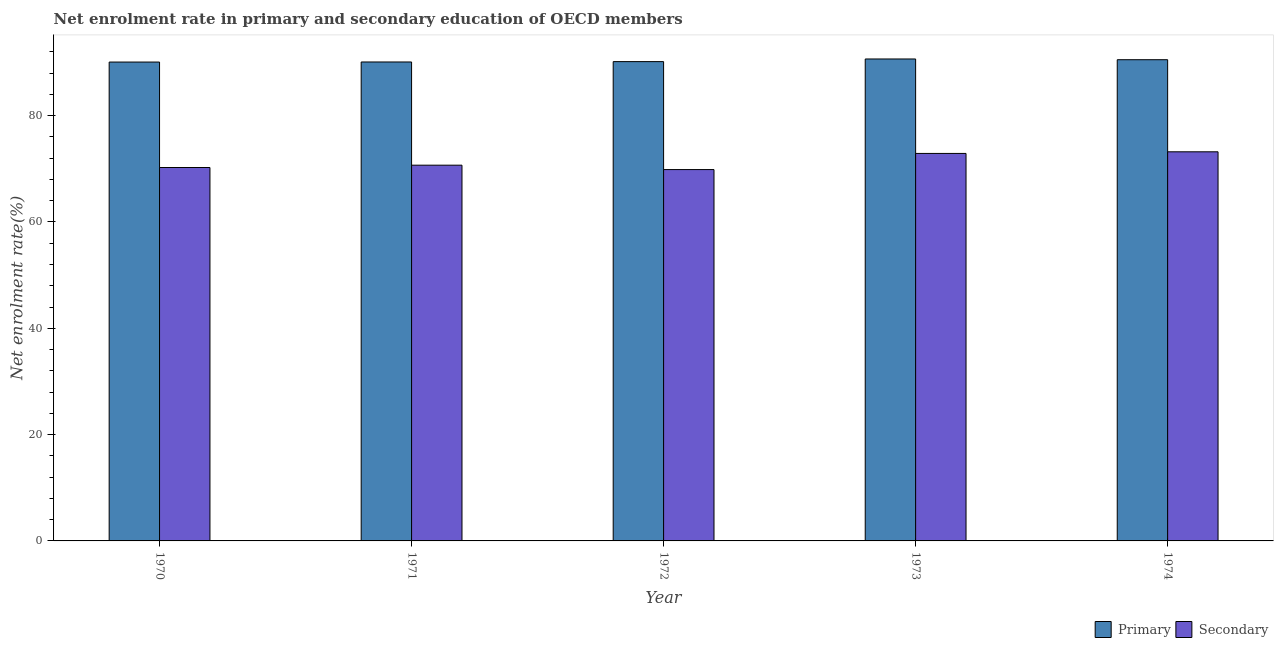How many groups of bars are there?
Your answer should be compact. 5. How many bars are there on the 1st tick from the right?
Provide a succinct answer. 2. What is the label of the 5th group of bars from the left?
Provide a succinct answer. 1974. What is the enrollment rate in primary education in 1971?
Offer a very short reply. 90.09. Across all years, what is the maximum enrollment rate in secondary education?
Your answer should be very brief. 73.2. Across all years, what is the minimum enrollment rate in primary education?
Keep it short and to the point. 90.08. In which year was the enrollment rate in primary education maximum?
Offer a terse response. 1973. What is the total enrollment rate in primary education in the graph?
Your answer should be compact. 451.5. What is the difference between the enrollment rate in primary education in 1970 and that in 1973?
Keep it short and to the point. -0.58. What is the difference between the enrollment rate in primary education in 1973 and the enrollment rate in secondary education in 1970?
Offer a very short reply. 0.58. What is the average enrollment rate in secondary education per year?
Provide a short and direct response. 71.37. In the year 1972, what is the difference between the enrollment rate in secondary education and enrollment rate in primary education?
Your answer should be very brief. 0. What is the ratio of the enrollment rate in secondary education in 1970 to that in 1974?
Make the answer very short. 0.96. What is the difference between the highest and the second highest enrollment rate in primary education?
Your response must be concise. 0.14. What is the difference between the highest and the lowest enrollment rate in secondary education?
Your answer should be very brief. 3.34. What does the 1st bar from the left in 1970 represents?
Offer a very short reply. Primary. What does the 1st bar from the right in 1971 represents?
Keep it short and to the point. Secondary. How many bars are there?
Ensure brevity in your answer.  10. How many years are there in the graph?
Make the answer very short. 5. What is the difference between two consecutive major ticks on the Y-axis?
Offer a terse response. 20. Are the values on the major ticks of Y-axis written in scientific E-notation?
Ensure brevity in your answer.  No. Does the graph contain any zero values?
Offer a terse response. No. Where does the legend appear in the graph?
Provide a succinct answer. Bottom right. How many legend labels are there?
Ensure brevity in your answer.  2. What is the title of the graph?
Your answer should be very brief. Net enrolment rate in primary and secondary education of OECD members. Does "Birth rate" appear as one of the legend labels in the graph?
Make the answer very short. No. What is the label or title of the X-axis?
Provide a succinct answer. Year. What is the label or title of the Y-axis?
Keep it short and to the point. Net enrolment rate(%). What is the Net enrolment rate(%) of Primary in 1970?
Make the answer very short. 90.08. What is the Net enrolment rate(%) of Secondary in 1970?
Your response must be concise. 70.24. What is the Net enrolment rate(%) in Primary in 1971?
Keep it short and to the point. 90.09. What is the Net enrolment rate(%) in Secondary in 1971?
Ensure brevity in your answer.  70.68. What is the Net enrolment rate(%) in Primary in 1972?
Give a very brief answer. 90.16. What is the Net enrolment rate(%) in Secondary in 1972?
Offer a terse response. 69.85. What is the Net enrolment rate(%) in Primary in 1973?
Give a very brief answer. 90.66. What is the Net enrolment rate(%) in Secondary in 1973?
Give a very brief answer. 72.89. What is the Net enrolment rate(%) of Primary in 1974?
Keep it short and to the point. 90.52. What is the Net enrolment rate(%) of Secondary in 1974?
Give a very brief answer. 73.2. Across all years, what is the maximum Net enrolment rate(%) of Primary?
Your response must be concise. 90.66. Across all years, what is the maximum Net enrolment rate(%) of Secondary?
Make the answer very short. 73.2. Across all years, what is the minimum Net enrolment rate(%) in Primary?
Provide a succinct answer. 90.08. Across all years, what is the minimum Net enrolment rate(%) in Secondary?
Your answer should be compact. 69.85. What is the total Net enrolment rate(%) in Primary in the graph?
Provide a short and direct response. 451.5. What is the total Net enrolment rate(%) of Secondary in the graph?
Offer a terse response. 356.85. What is the difference between the Net enrolment rate(%) in Primary in 1970 and that in 1971?
Ensure brevity in your answer.  -0.01. What is the difference between the Net enrolment rate(%) in Secondary in 1970 and that in 1971?
Offer a terse response. -0.44. What is the difference between the Net enrolment rate(%) in Primary in 1970 and that in 1972?
Offer a terse response. -0.08. What is the difference between the Net enrolment rate(%) of Secondary in 1970 and that in 1972?
Offer a terse response. 0.39. What is the difference between the Net enrolment rate(%) of Primary in 1970 and that in 1973?
Offer a very short reply. -0.58. What is the difference between the Net enrolment rate(%) of Secondary in 1970 and that in 1973?
Keep it short and to the point. -2.65. What is the difference between the Net enrolment rate(%) in Primary in 1970 and that in 1974?
Your response must be concise. -0.44. What is the difference between the Net enrolment rate(%) in Secondary in 1970 and that in 1974?
Provide a short and direct response. -2.96. What is the difference between the Net enrolment rate(%) of Primary in 1971 and that in 1972?
Provide a short and direct response. -0.07. What is the difference between the Net enrolment rate(%) of Secondary in 1971 and that in 1972?
Your response must be concise. 0.82. What is the difference between the Net enrolment rate(%) in Primary in 1971 and that in 1973?
Your response must be concise. -0.57. What is the difference between the Net enrolment rate(%) of Secondary in 1971 and that in 1973?
Your answer should be compact. -2.21. What is the difference between the Net enrolment rate(%) in Primary in 1971 and that in 1974?
Provide a succinct answer. -0.43. What is the difference between the Net enrolment rate(%) of Secondary in 1971 and that in 1974?
Provide a short and direct response. -2.52. What is the difference between the Net enrolment rate(%) of Primary in 1972 and that in 1973?
Offer a terse response. -0.5. What is the difference between the Net enrolment rate(%) of Secondary in 1972 and that in 1973?
Offer a very short reply. -3.04. What is the difference between the Net enrolment rate(%) of Primary in 1972 and that in 1974?
Your response must be concise. -0.36. What is the difference between the Net enrolment rate(%) of Secondary in 1972 and that in 1974?
Keep it short and to the point. -3.34. What is the difference between the Net enrolment rate(%) of Primary in 1973 and that in 1974?
Your response must be concise. 0.14. What is the difference between the Net enrolment rate(%) in Secondary in 1973 and that in 1974?
Make the answer very short. -0.31. What is the difference between the Net enrolment rate(%) in Primary in 1970 and the Net enrolment rate(%) in Secondary in 1971?
Keep it short and to the point. 19.4. What is the difference between the Net enrolment rate(%) of Primary in 1970 and the Net enrolment rate(%) of Secondary in 1972?
Offer a terse response. 20.22. What is the difference between the Net enrolment rate(%) of Primary in 1970 and the Net enrolment rate(%) of Secondary in 1973?
Your response must be concise. 17.19. What is the difference between the Net enrolment rate(%) of Primary in 1970 and the Net enrolment rate(%) of Secondary in 1974?
Provide a succinct answer. 16.88. What is the difference between the Net enrolment rate(%) of Primary in 1971 and the Net enrolment rate(%) of Secondary in 1972?
Provide a succinct answer. 20.24. What is the difference between the Net enrolment rate(%) in Primary in 1971 and the Net enrolment rate(%) in Secondary in 1973?
Ensure brevity in your answer.  17.2. What is the difference between the Net enrolment rate(%) in Primary in 1971 and the Net enrolment rate(%) in Secondary in 1974?
Ensure brevity in your answer.  16.89. What is the difference between the Net enrolment rate(%) of Primary in 1972 and the Net enrolment rate(%) of Secondary in 1973?
Keep it short and to the point. 17.27. What is the difference between the Net enrolment rate(%) of Primary in 1972 and the Net enrolment rate(%) of Secondary in 1974?
Provide a short and direct response. 16.96. What is the difference between the Net enrolment rate(%) in Primary in 1973 and the Net enrolment rate(%) in Secondary in 1974?
Give a very brief answer. 17.46. What is the average Net enrolment rate(%) of Primary per year?
Provide a succinct answer. 90.3. What is the average Net enrolment rate(%) in Secondary per year?
Provide a succinct answer. 71.37. In the year 1970, what is the difference between the Net enrolment rate(%) in Primary and Net enrolment rate(%) in Secondary?
Your response must be concise. 19.84. In the year 1971, what is the difference between the Net enrolment rate(%) of Primary and Net enrolment rate(%) of Secondary?
Provide a short and direct response. 19.41. In the year 1972, what is the difference between the Net enrolment rate(%) in Primary and Net enrolment rate(%) in Secondary?
Give a very brief answer. 20.31. In the year 1973, what is the difference between the Net enrolment rate(%) of Primary and Net enrolment rate(%) of Secondary?
Offer a very short reply. 17.77. In the year 1974, what is the difference between the Net enrolment rate(%) of Primary and Net enrolment rate(%) of Secondary?
Your answer should be compact. 17.32. What is the ratio of the Net enrolment rate(%) of Primary in 1970 to that in 1972?
Your answer should be compact. 1. What is the ratio of the Net enrolment rate(%) in Secondary in 1970 to that in 1972?
Your answer should be very brief. 1.01. What is the ratio of the Net enrolment rate(%) in Secondary in 1970 to that in 1973?
Ensure brevity in your answer.  0.96. What is the ratio of the Net enrolment rate(%) in Primary in 1970 to that in 1974?
Offer a very short reply. 1. What is the ratio of the Net enrolment rate(%) in Secondary in 1970 to that in 1974?
Give a very brief answer. 0.96. What is the ratio of the Net enrolment rate(%) of Primary in 1971 to that in 1972?
Provide a short and direct response. 1. What is the ratio of the Net enrolment rate(%) in Secondary in 1971 to that in 1972?
Ensure brevity in your answer.  1.01. What is the ratio of the Net enrolment rate(%) of Secondary in 1971 to that in 1973?
Give a very brief answer. 0.97. What is the ratio of the Net enrolment rate(%) of Secondary in 1971 to that in 1974?
Offer a very short reply. 0.97. What is the ratio of the Net enrolment rate(%) of Primary in 1972 to that in 1973?
Provide a short and direct response. 0.99. What is the ratio of the Net enrolment rate(%) of Secondary in 1972 to that in 1973?
Your response must be concise. 0.96. What is the ratio of the Net enrolment rate(%) in Secondary in 1972 to that in 1974?
Offer a terse response. 0.95. What is the ratio of the Net enrolment rate(%) in Primary in 1973 to that in 1974?
Your response must be concise. 1. What is the ratio of the Net enrolment rate(%) in Secondary in 1973 to that in 1974?
Offer a very short reply. 1. What is the difference between the highest and the second highest Net enrolment rate(%) of Primary?
Give a very brief answer. 0.14. What is the difference between the highest and the second highest Net enrolment rate(%) in Secondary?
Your answer should be very brief. 0.31. What is the difference between the highest and the lowest Net enrolment rate(%) of Primary?
Your answer should be very brief. 0.58. What is the difference between the highest and the lowest Net enrolment rate(%) of Secondary?
Provide a short and direct response. 3.34. 